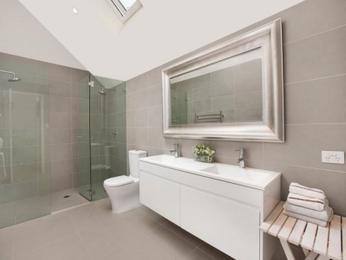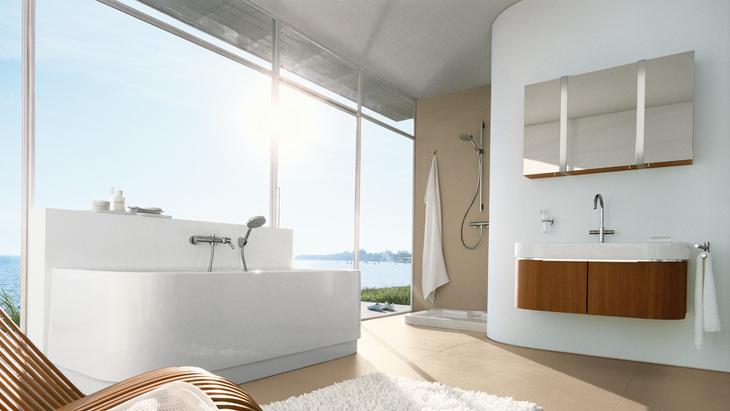The first image is the image on the left, the second image is the image on the right. For the images shown, is this caption "There are two separate but raised square sinks sitting on top of a wooden cabinet facing front left." true? Answer yes or no. No. 